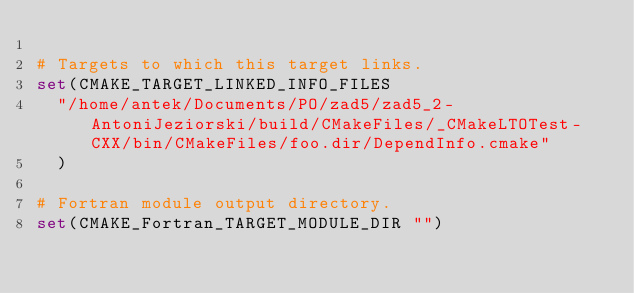Convert code to text. <code><loc_0><loc_0><loc_500><loc_500><_CMake_>
# Targets to which this target links.
set(CMAKE_TARGET_LINKED_INFO_FILES
  "/home/antek/Documents/PO/zad5/zad5_2-AntoniJeziorski/build/CMakeFiles/_CMakeLTOTest-CXX/bin/CMakeFiles/foo.dir/DependInfo.cmake"
  )

# Fortran module output directory.
set(CMAKE_Fortran_TARGET_MODULE_DIR "")
</code> 